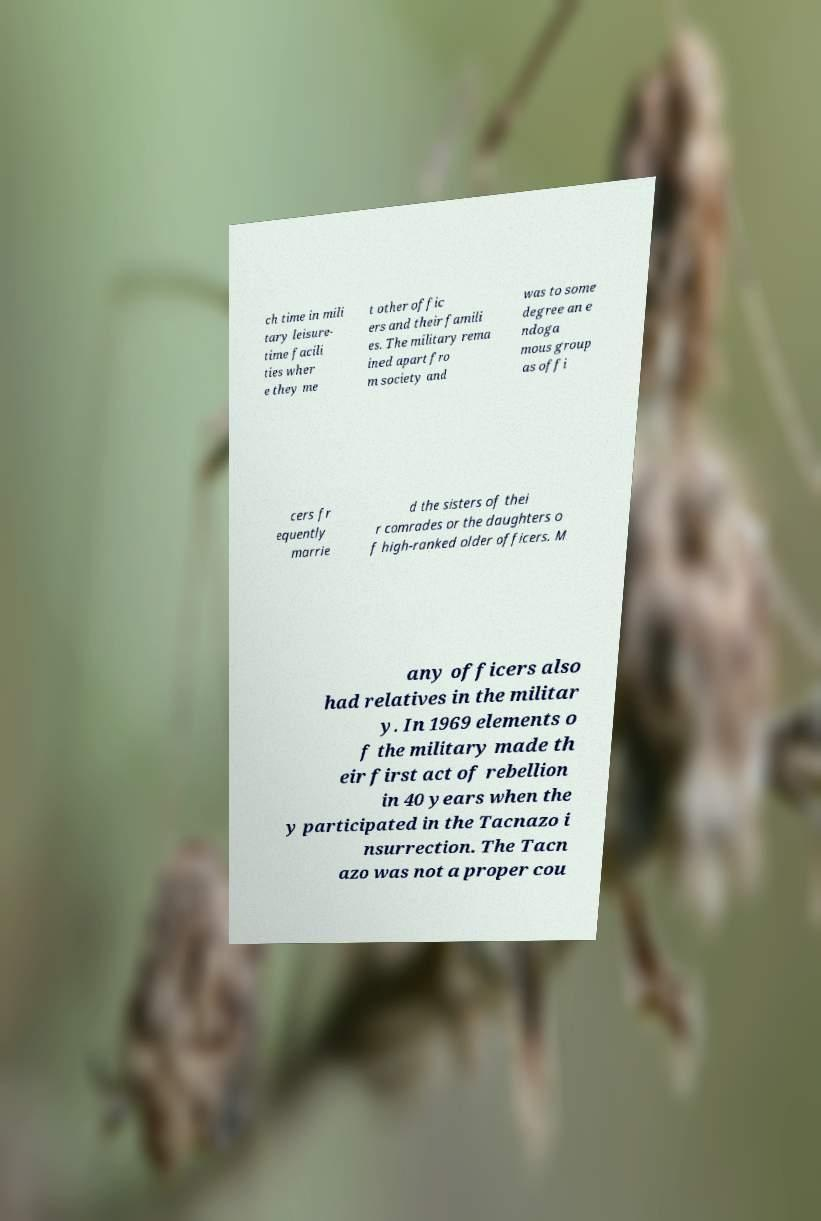Could you assist in decoding the text presented in this image and type it out clearly? ch time in mili tary leisure- time facili ties wher e they me t other offic ers and their famili es. The military rema ined apart fro m society and was to some degree an e ndoga mous group as offi cers fr equently marrie d the sisters of thei r comrades or the daughters o f high-ranked older officers. M any officers also had relatives in the militar y. In 1969 elements o f the military made th eir first act of rebellion in 40 years when the y participated in the Tacnazo i nsurrection. The Tacn azo was not a proper cou 